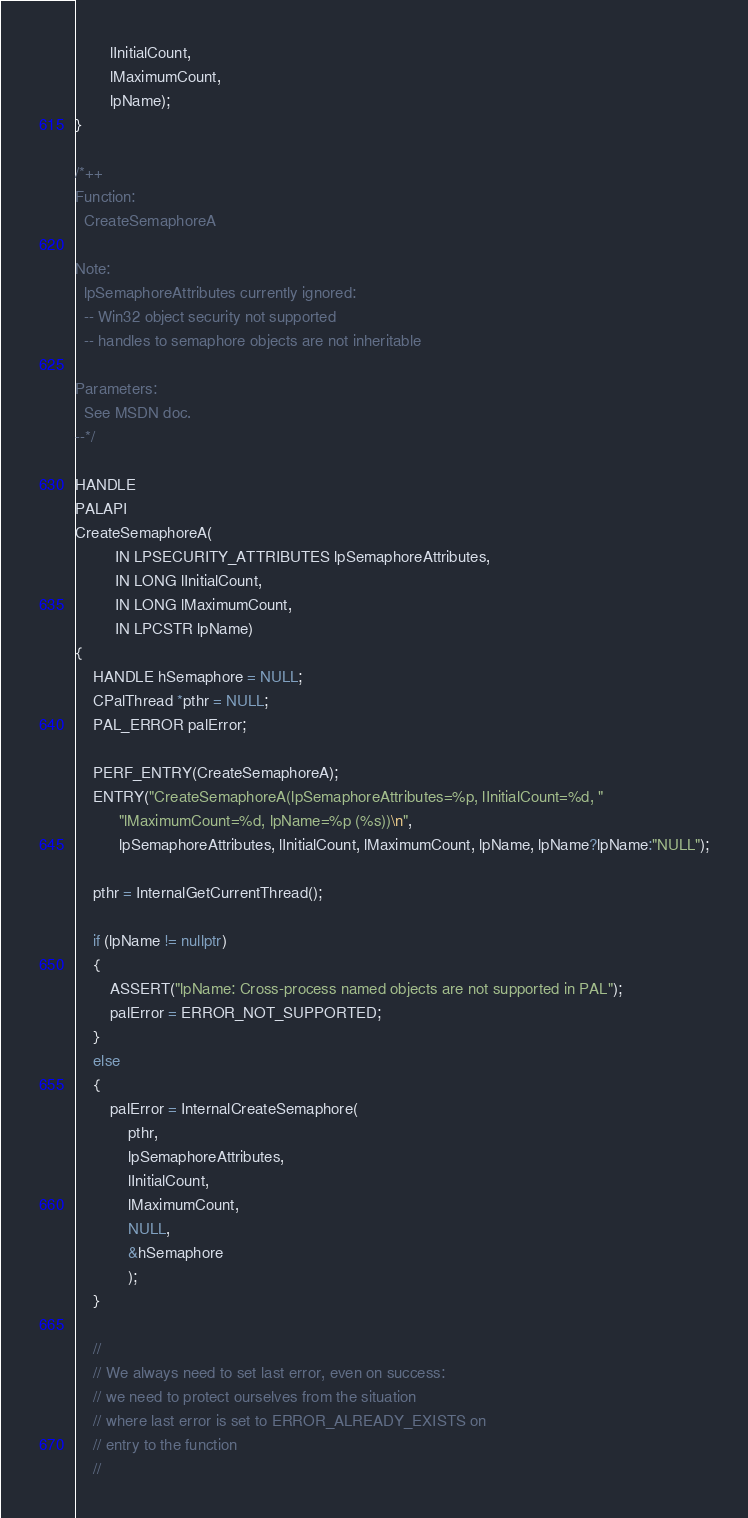Convert code to text. <code><loc_0><loc_0><loc_500><loc_500><_C++_>        lInitialCount,
        lMaximumCount,
        lpName);
}

/*++
Function:
  CreateSemaphoreA

Note:
  lpSemaphoreAttributes currently ignored:
  -- Win32 object security not supported
  -- handles to semaphore objects are not inheritable

Parameters:
  See MSDN doc.
--*/

HANDLE
PALAPI
CreateSemaphoreA(
         IN LPSECURITY_ATTRIBUTES lpSemaphoreAttributes,
         IN LONG lInitialCount,
         IN LONG lMaximumCount,
         IN LPCSTR lpName)
{
    HANDLE hSemaphore = NULL;
    CPalThread *pthr = NULL;
    PAL_ERROR palError;

    PERF_ENTRY(CreateSemaphoreA);
    ENTRY("CreateSemaphoreA(lpSemaphoreAttributes=%p, lInitialCount=%d, "
          "lMaximumCount=%d, lpName=%p (%s))\n",
          lpSemaphoreAttributes, lInitialCount, lMaximumCount, lpName, lpName?lpName:"NULL");

    pthr = InternalGetCurrentThread();

    if (lpName != nullptr)
    {
        ASSERT("lpName: Cross-process named objects are not supported in PAL");
        palError = ERROR_NOT_SUPPORTED;
    }
    else
    {
        palError = InternalCreateSemaphore(
            pthr,
            lpSemaphoreAttributes,
            lInitialCount,
            lMaximumCount,
            NULL,
            &hSemaphore
            );
    }

    //
    // We always need to set last error, even on success:
    // we need to protect ourselves from the situation
    // where last error is set to ERROR_ALREADY_EXISTS on
    // entry to the function
    //
</code> 